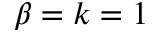Convert formula to latex. <formula><loc_0><loc_0><loc_500><loc_500>\beta = k = 1</formula> 